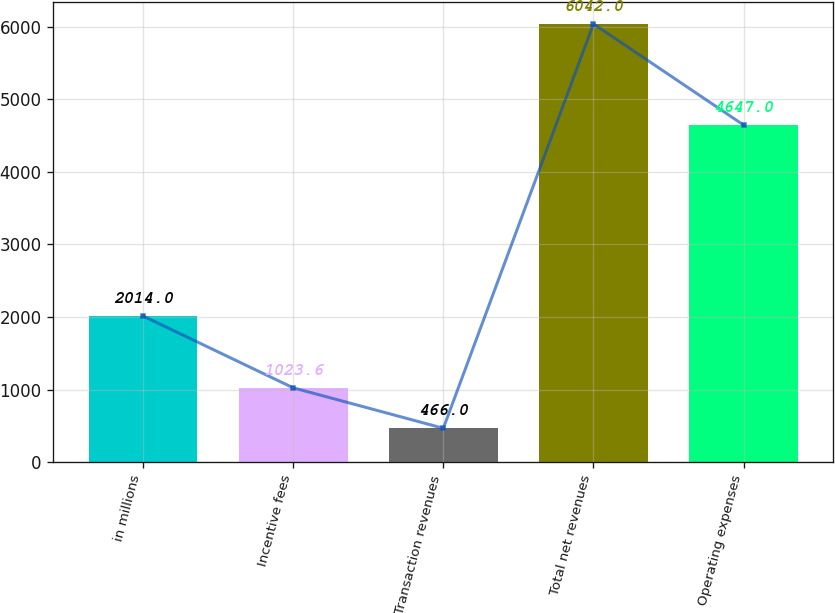<chart> <loc_0><loc_0><loc_500><loc_500><bar_chart><fcel>in millions<fcel>Incentive fees<fcel>Transaction revenues<fcel>Total net revenues<fcel>Operating expenses<nl><fcel>2014<fcel>1023.6<fcel>466<fcel>6042<fcel>4647<nl></chart> 